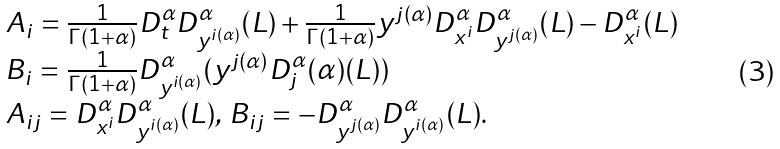Convert formula to latex. <formula><loc_0><loc_0><loc_500><loc_500>\begin{array} { l } { A _ { i } = \frac { 1 } { \Gamma ( 1 + \alpha ) } D _ { t } ^ { \alpha } D _ { y ^ { i ( \alpha ) } } ^ { \alpha } ( L ) + \frac { 1 } { \Gamma ( 1 + \alpha ) } y ^ { j ( \alpha ) } D _ { x ^ { i } } ^ { \alpha } D _ { y ^ { j ( \alpha ) } } ^ { \alpha } ( L ) - D _ { x ^ { i } } ^ { \alpha } ( L ) } \\ { B _ { i } = \frac { 1 } { \Gamma ( 1 + \alpha ) } D _ { y ^ { i ( \alpha ) } } ^ { \alpha } ( y ^ { j ( \alpha ) } D _ { j } ^ { \alpha } ( \alpha ) ( L ) ) } \\ { A _ { i j } = D _ { x ^ { i } } ^ { \alpha } D _ { y ^ { i ( \alpha ) } } ^ { \alpha } ( L ) , \, B _ { i j } = - D _ { y ^ { j ( \alpha ) } } ^ { \alpha } D _ { y ^ { i ( \alpha ) } } ^ { \alpha } ( L ) . } \end{array}</formula> 